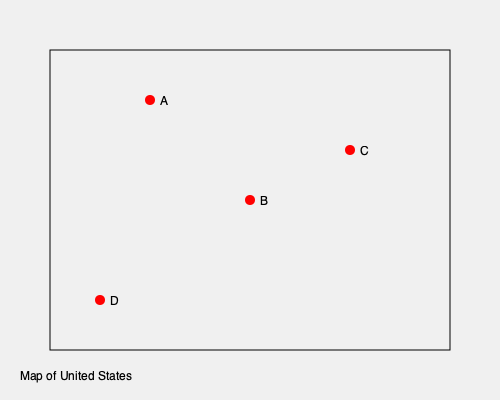On this simplified map of the United States, which point represents Indianapolis, the city where Kurt Vonnegut was born and spent his formative years? To answer this question, we need to consider Kurt Vonnegut's biographical information and geographical knowledge of the United States:

1. Kurt Vonnegut was born in Indianapolis, Indiana, on November 11, 1922.
2. Indianapolis is located in the Midwest region of the United States.
3. On the simplified map:
   - Point A appears to be in the upper Midwest, possibly representing a city like Chicago or Detroit.
   - Point B is centrally located, which aligns with Indianapolis's position.
   - Point C is too far east, possibly representing a city on the East Coast.
   - Point D is too far south, possibly representing a southern city like New Orleans.
4. Given Indianapolis's central location in the Midwest, point B best represents its position on this simplified map.

Therefore, the point that represents Indianapolis, where Kurt Vonnegut was born and spent his formative years, is point B.
Answer: B 